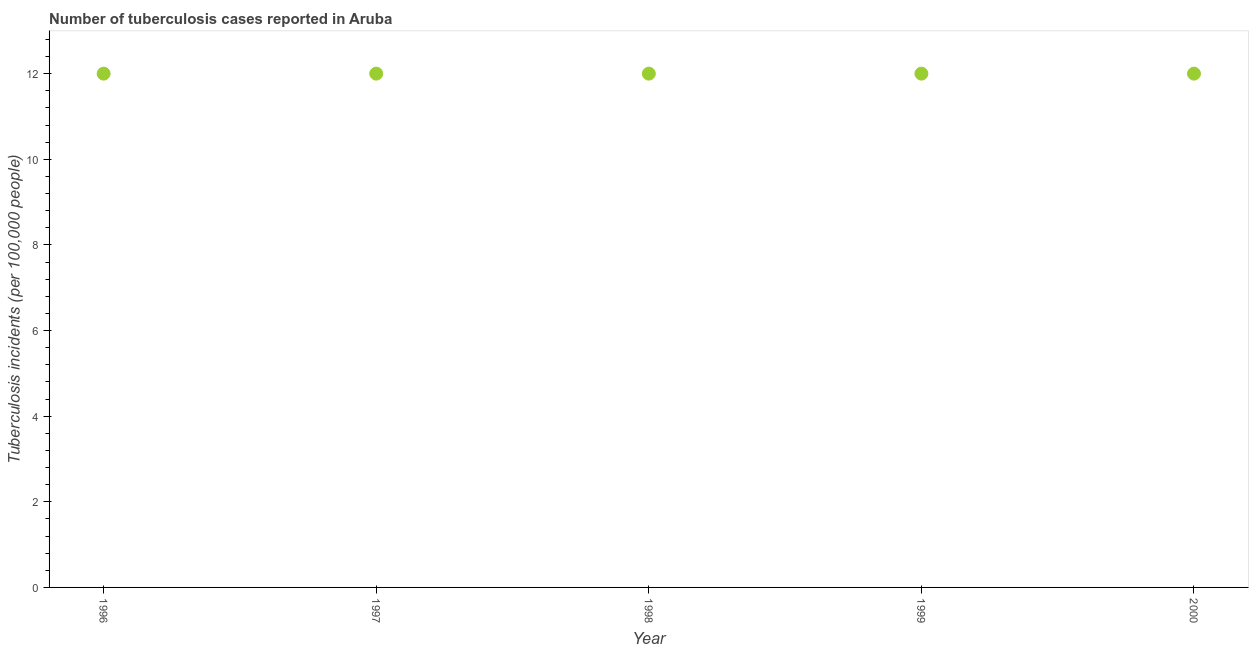What is the number of tuberculosis incidents in 1996?
Give a very brief answer. 12. Across all years, what is the maximum number of tuberculosis incidents?
Offer a terse response. 12. Across all years, what is the minimum number of tuberculosis incidents?
Make the answer very short. 12. In which year was the number of tuberculosis incidents maximum?
Ensure brevity in your answer.  1996. What is the sum of the number of tuberculosis incidents?
Give a very brief answer. 60. What is the difference between the number of tuberculosis incidents in 1996 and 1999?
Offer a very short reply. 0. What is the average number of tuberculosis incidents per year?
Make the answer very short. 12. Do a majority of the years between 1998 and 1999 (inclusive) have number of tuberculosis incidents greater than 12 ?
Provide a short and direct response. No. Is the difference between the number of tuberculosis incidents in 1998 and 2000 greater than the difference between any two years?
Your response must be concise. Yes. What is the difference between the highest and the second highest number of tuberculosis incidents?
Offer a terse response. 0. What is the difference between the highest and the lowest number of tuberculosis incidents?
Your response must be concise. 0. In how many years, is the number of tuberculosis incidents greater than the average number of tuberculosis incidents taken over all years?
Ensure brevity in your answer.  0. Does the number of tuberculosis incidents monotonically increase over the years?
Your answer should be compact. No. How many dotlines are there?
Provide a succinct answer. 1. How many years are there in the graph?
Provide a short and direct response. 5. What is the difference between two consecutive major ticks on the Y-axis?
Ensure brevity in your answer.  2. Are the values on the major ticks of Y-axis written in scientific E-notation?
Your answer should be compact. No. Does the graph contain any zero values?
Provide a succinct answer. No. What is the title of the graph?
Offer a terse response. Number of tuberculosis cases reported in Aruba. What is the label or title of the Y-axis?
Your answer should be compact. Tuberculosis incidents (per 100,0 people). What is the Tuberculosis incidents (per 100,000 people) in 1996?
Your answer should be very brief. 12. What is the Tuberculosis incidents (per 100,000 people) in 1998?
Provide a succinct answer. 12. What is the Tuberculosis incidents (per 100,000 people) in 1999?
Your response must be concise. 12. What is the Tuberculosis incidents (per 100,000 people) in 2000?
Offer a very short reply. 12. What is the difference between the Tuberculosis incidents (per 100,000 people) in 1996 and 1998?
Give a very brief answer. 0. What is the difference between the Tuberculosis incidents (per 100,000 people) in 1997 and 1998?
Ensure brevity in your answer.  0. What is the difference between the Tuberculosis incidents (per 100,000 people) in 1997 and 2000?
Your answer should be very brief. 0. What is the difference between the Tuberculosis incidents (per 100,000 people) in 1998 and 1999?
Give a very brief answer. 0. What is the difference between the Tuberculosis incidents (per 100,000 people) in 1998 and 2000?
Offer a very short reply. 0. What is the difference between the Tuberculosis incidents (per 100,000 people) in 1999 and 2000?
Your answer should be compact. 0. What is the ratio of the Tuberculosis incidents (per 100,000 people) in 1996 to that in 1997?
Give a very brief answer. 1. What is the ratio of the Tuberculosis incidents (per 100,000 people) in 1996 to that in 1998?
Offer a terse response. 1. What is the ratio of the Tuberculosis incidents (per 100,000 people) in 1996 to that in 1999?
Offer a very short reply. 1. What is the ratio of the Tuberculosis incidents (per 100,000 people) in 1997 to that in 1998?
Your response must be concise. 1. What is the ratio of the Tuberculosis incidents (per 100,000 people) in 1997 to that in 1999?
Make the answer very short. 1. What is the ratio of the Tuberculosis incidents (per 100,000 people) in 1997 to that in 2000?
Offer a very short reply. 1. What is the ratio of the Tuberculosis incidents (per 100,000 people) in 1998 to that in 1999?
Make the answer very short. 1. What is the ratio of the Tuberculosis incidents (per 100,000 people) in 1999 to that in 2000?
Ensure brevity in your answer.  1. 